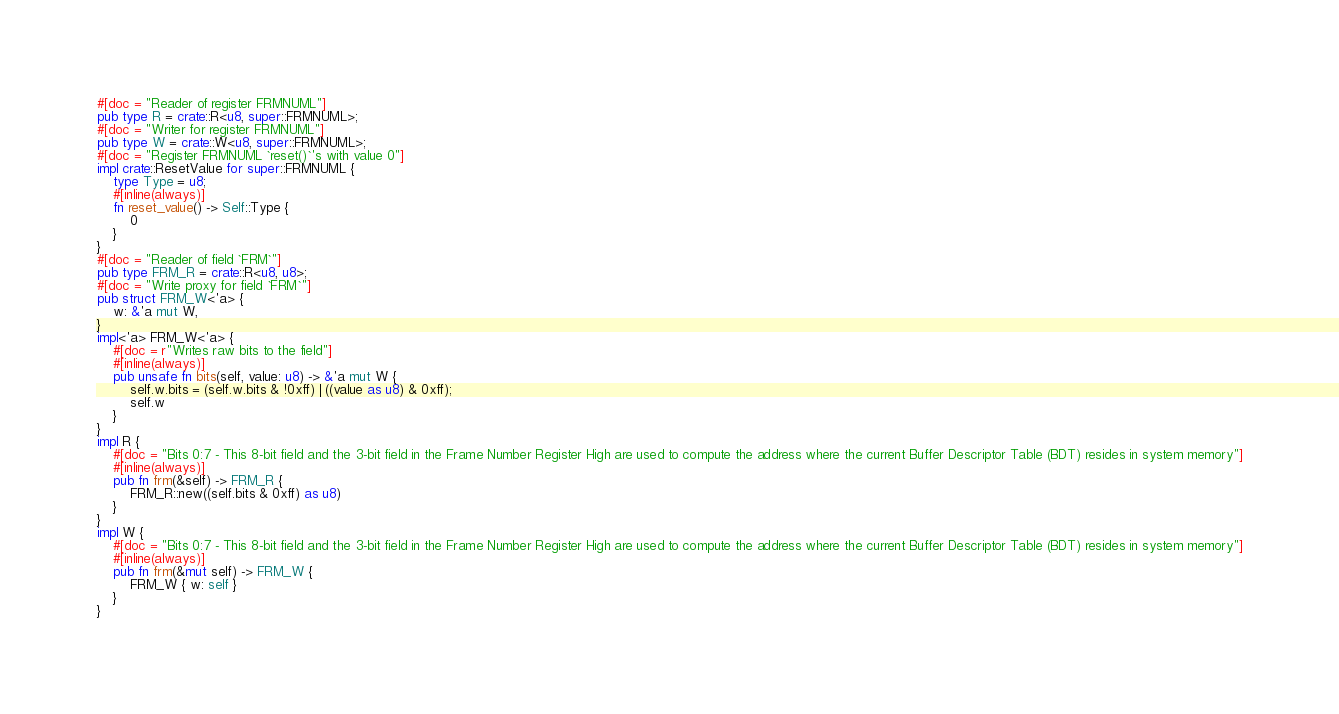<code> <loc_0><loc_0><loc_500><loc_500><_Rust_>#[doc = "Reader of register FRMNUML"]
pub type R = crate::R<u8, super::FRMNUML>;
#[doc = "Writer for register FRMNUML"]
pub type W = crate::W<u8, super::FRMNUML>;
#[doc = "Register FRMNUML `reset()`'s with value 0"]
impl crate::ResetValue for super::FRMNUML {
    type Type = u8;
    #[inline(always)]
    fn reset_value() -> Self::Type {
        0
    }
}
#[doc = "Reader of field `FRM`"]
pub type FRM_R = crate::R<u8, u8>;
#[doc = "Write proxy for field `FRM`"]
pub struct FRM_W<'a> {
    w: &'a mut W,
}
impl<'a> FRM_W<'a> {
    #[doc = r"Writes raw bits to the field"]
    #[inline(always)]
    pub unsafe fn bits(self, value: u8) -> &'a mut W {
        self.w.bits = (self.w.bits & !0xff) | ((value as u8) & 0xff);
        self.w
    }
}
impl R {
    #[doc = "Bits 0:7 - This 8-bit field and the 3-bit field in the Frame Number Register High are used to compute the address where the current Buffer Descriptor Table (BDT) resides in system memory"]
    #[inline(always)]
    pub fn frm(&self) -> FRM_R {
        FRM_R::new((self.bits & 0xff) as u8)
    }
}
impl W {
    #[doc = "Bits 0:7 - This 8-bit field and the 3-bit field in the Frame Number Register High are used to compute the address where the current Buffer Descriptor Table (BDT) resides in system memory"]
    #[inline(always)]
    pub fn frm(&mut self) -> FRM_W {
        FRM_W { w: self }
    }
}
</code> 